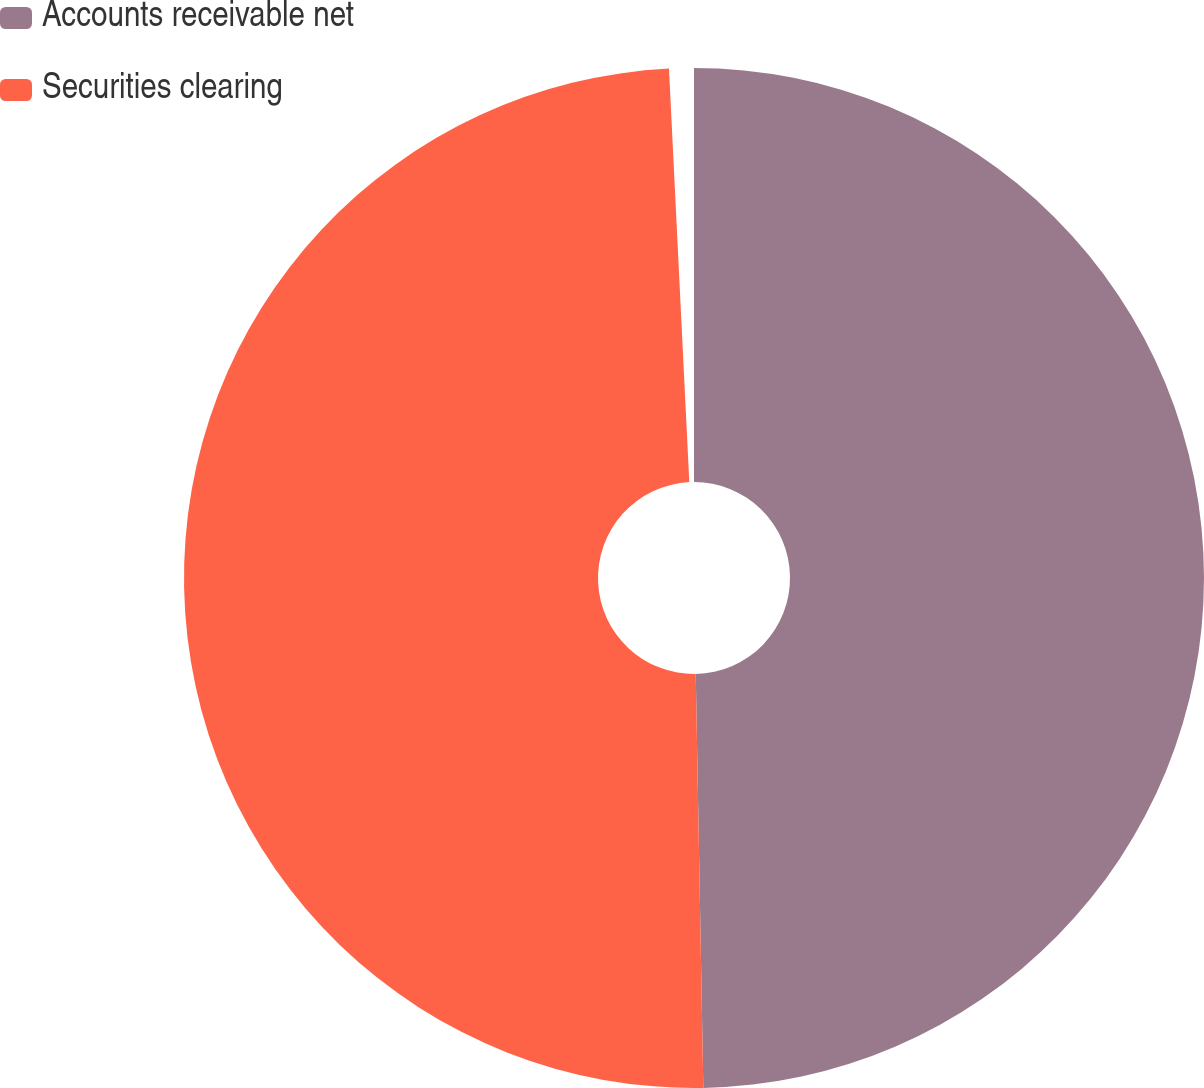Convert chart to OTSL. <chart><loc_0><loc_0><loc_500><loc_500><pie_chart><fcel>Accounts receivable net<fcel>Securities clearing<nl><fcel>50.1%<fcel>49.9%<nl></chart> 